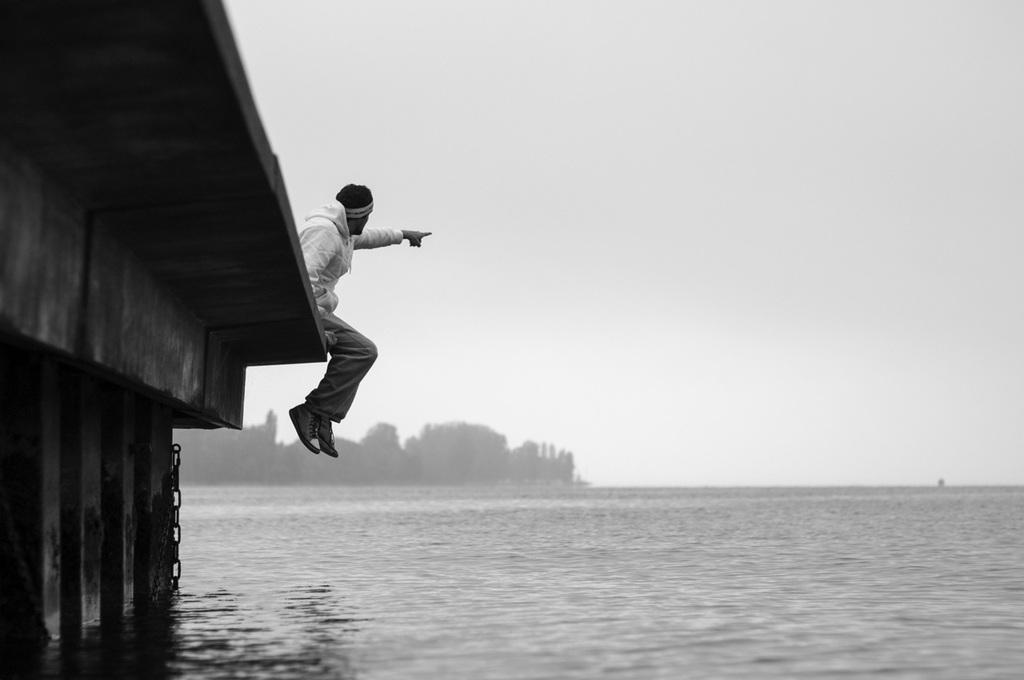What is the man in the image doing? The man is sitting on the bridge in the image. What is the man wearing? The man is wearing a coat, trousers, shoes, and a cap. What can be seen at the bottom of the image? There is water at the bottom of the image. What is visible at the top of the image? The sky is visible at the top of the image. What type of meat is the man holding in the image? There is no meat present in the image; the man is not holding any food items. How much profit is the man making from sitting on the bridge in the image? There is no indication of profit or financial gain in the image; the man is simply sitting on the bridge. 